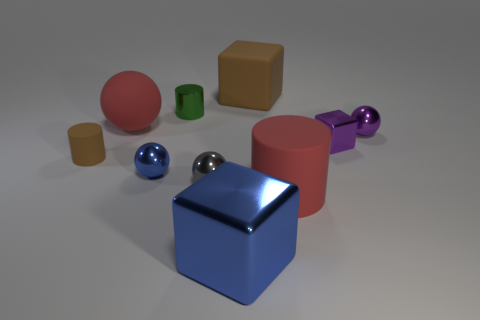Subtract all balls. How many objects are left? 6 Subtract all rubber spheres. Subtract all red rubber spheres. How many objects are left? 8 Add 1 big blue objects. How many big blue objects are left? 2 Add 9 large metallic objects. How many large metallic objects exist? 10 Subtract 0 purple cylinders. How many objects are left? 10 